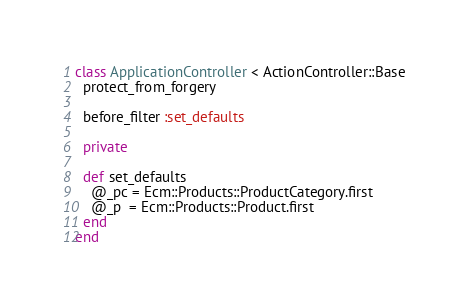Convert code to text. <code><loc_0><loc_0><loc_500><loc_500><_Ruby_>class ApplicationController < ActionController::Base
  protect_from_forgery
  
  before_filter :set_defaults
  
  private
  
  def set_defaults
    @_pc = Ecm::Products::ProductCategory.first
    @_p  = Ecm::Products::Product.first
  end
end
</code> 